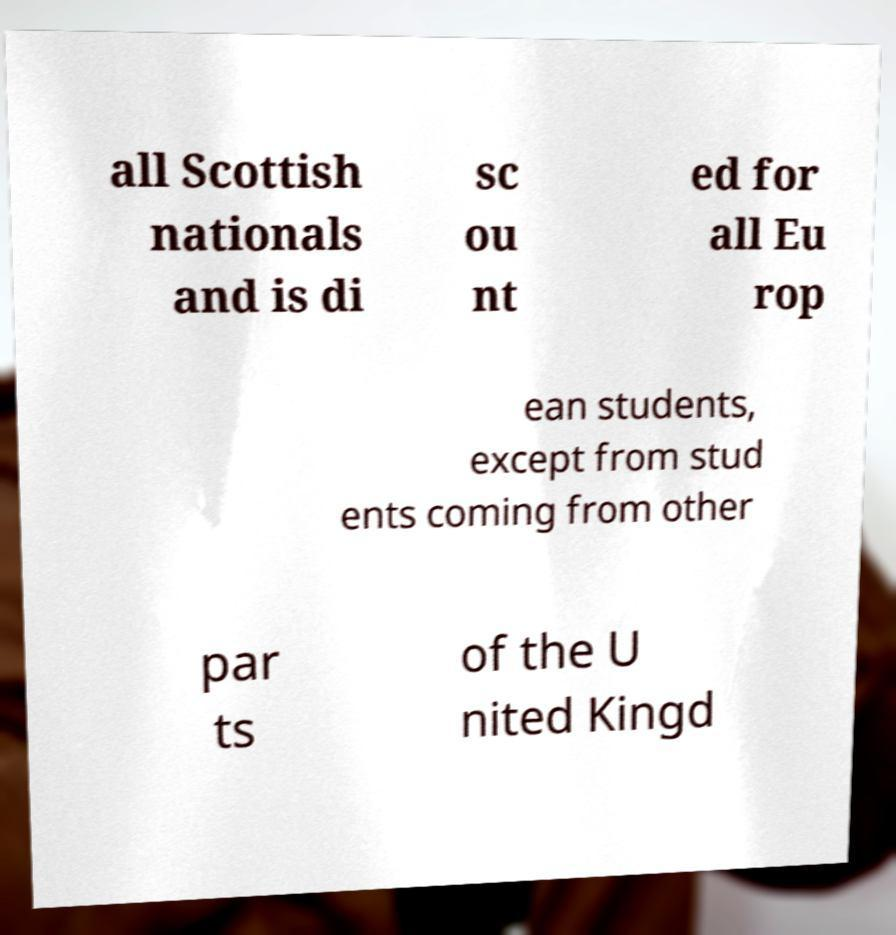Could you extract and type out the text from this image? all Scottish nationals and is di sc ou nt ed for all Eu rop ean students, except from stud ents coming from other par ts of the U nited Kingd 